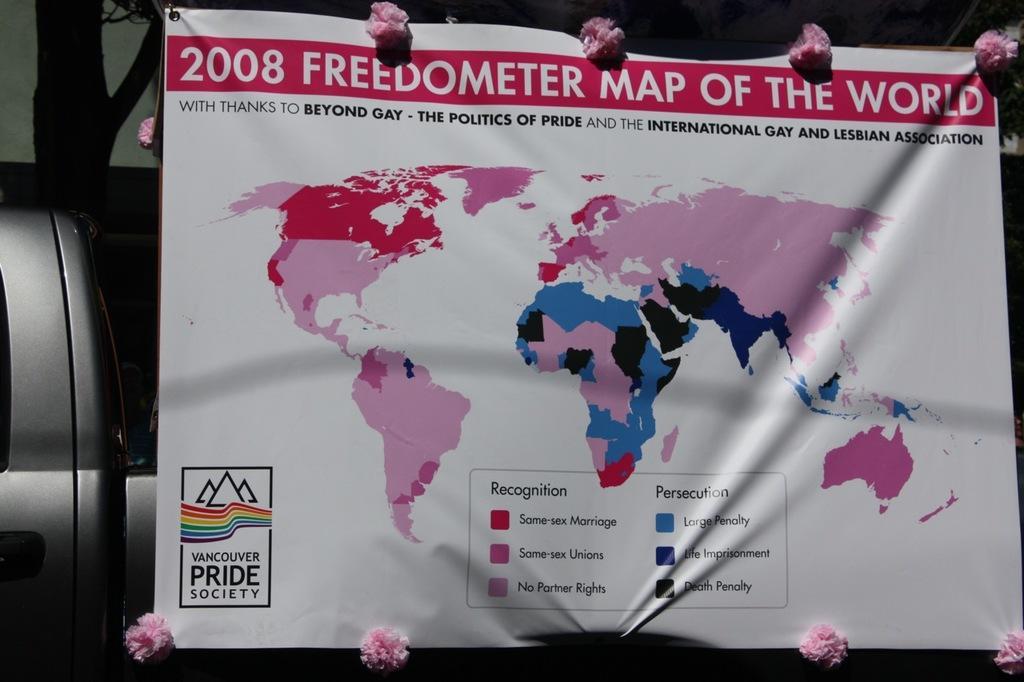How would you summarize this image in a sentence or two? In the center of the image a banner is there. On the left side of the image we can see a vehicle and tree are there. 